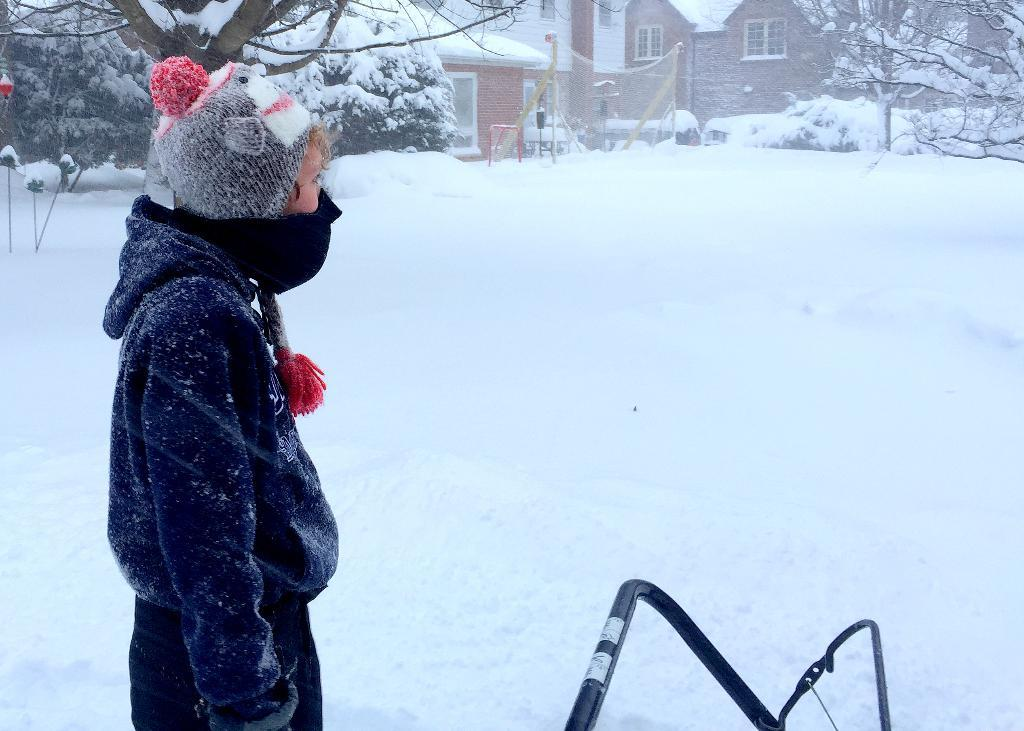What is the person in the image wearing? The person is wearing a blue dress. What can be seen in the background of the image? There are trees covered with snow and buildings visible in the background of the image. What type of jam is the person holding in the image? There is no jam present in the image. What hobbies does the person in the image have? The provided facts do not give any information about the person's hobbies. --- Facts: 1. There is a car in the image. 2. The car is red. 3. The car has four wheels. 4. There are people sitting inside the car. 5. The car is parked on the street. Absurd Topics: parrot, dance, ocean Conversation: What color is the car in the image? The car is red. How many wheels does the car have? The car has four wheels. What is the car's current location in the image? The car is parked on the street. Are there any passengers inside the car? Yes, there are people sitting inside the car. Reasoning: Let's think step by step in order to produce the conversation. We start by identifying the main subject in the image, which is the car. Then, we describe the car's color, number of wheels, and location. Next, we mention the presence of passengers inside the car. Each question is designed to elicit a specific detail about the image that is known from the provided facts. Absurd Question/Answer: Can you see a parrot dancing by the ocean in the image? No, there is no parrot or ocean present in the image. 